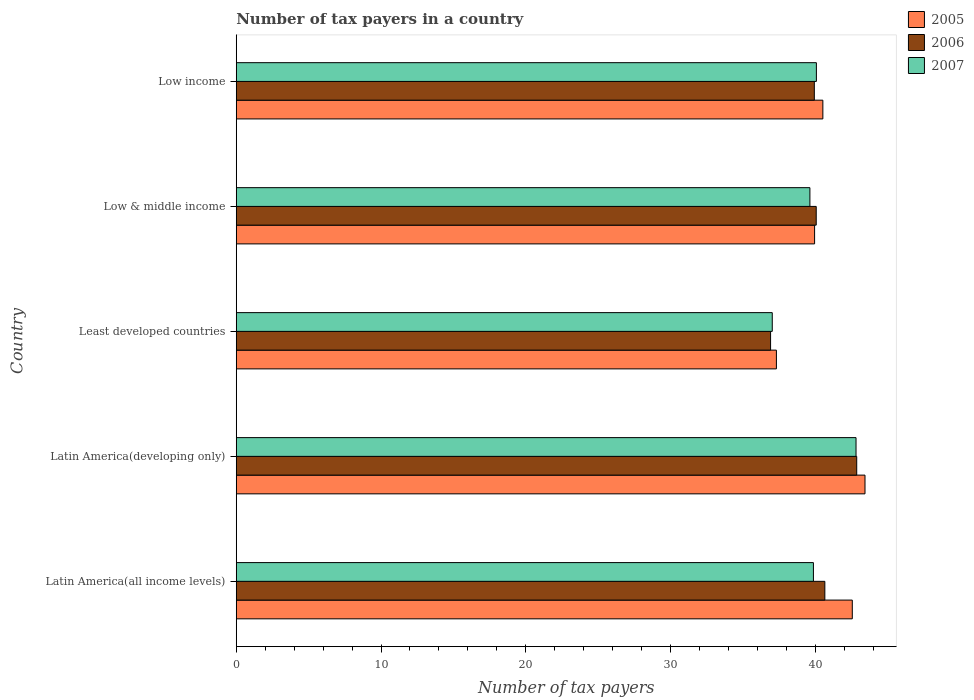How many groups of bars are there?
Offer a very short reply. 5. Are the number of bars per tick equal to the number of legend labels?
Keep it short and to the point. Yes. What is the label of the 4th group of bars from the top?
Your answer should be compact. Latin America(developing only). In how many cases, is the number of bars for a given country not equal to the number of legend labels?
Ensure brevity in your answer.  0. What is the number of tax payers in in 2005 in Latin America(all income levels)?
Make the answer very short. 42.55. Across all countries, what is the maximum number of tax payers in in 2005?
Offer a very short reply. 43.43. Across all countries, what is the minimum number of tax payers in in 2005?
Keep it short and to the point. 37.31. In which country was the number of tax payers in in 2007 maximum?
Offer a terse response. Latin America(developing only). In which country was the number of tax payers in in 2005 minimum?
Give a very brief answer. Least developed countries. What is the total number of tax payers in in 2005 in the graph?
Offer a terse response. 203.76. What is the difference between the number of tax payers in in 2007 in Latin America(all income levels) and that in Low & middle income?
Provide a short and direct response. 0.24. What is the difference between the number of tax payers in in 2006 in Low income and the number of tax payers in in 2005 in Least developed countries?
Your response must be concise. 2.62. What is the average number of tax payers in in 2005 per country?
Give a very brief answer. 40.75. What is the difference between the number of tax payers in in 2005 and number of tax payers in in 2007 in Latin America(developing only)?
Your response must be concise. 0.62. In how many countries, is the number of tax payers in in 2005 greater than 4 ?
Keep it short and to the point. 5. What is the ratio of the number of tax payers in in 2005 in Latin America(developing only) to that in Low & middle income?
Offer a terse response. 1.09. Is the number of tax payers in in 2005 in Least developed countries less than that in Low & middle income?
Provide a short and direct response. Yes. Is the difference between the number of tax payers in in 2005 in Least developed countries and Low & middle income greater than the difference between the number of tax payers in in 2007 in Least developed countries and Low & middle income?
Provide a succinct answer. No. What is the difference between the highest and the second highest number of tax payers in in 2005?
Your response must be concise. 0.88. What is the difference between the highest and the lowest number of tax payers in in 2005?
Give a very brief answer. 6.12. In how many countries, is the number of tax payers in in 2006 greater than the average number of tax payers in in 2006 taken over all countries?
Offer a terse response. 2. Is the sum of the number of tax payers in in 2005 in Latin America(developing only) and Low income greater than the maximum number of tax payers in in 2007 across all countries?
Keep it short and to the point. Yes. What does the 1st bar from the top in Low income represents?
Your response must be concise. 2007. How many bars are there?
Your answer should be compact. 15. Are all the bars in the graph horizontal?
Your answer should be compact. Yes. What is the difference between two consecutive major ticks on the X-axis?
Offer a very short reply. 10. Where does the legend appear in the graph?
Your answer should be very brief. Top right. How many legend labels are there?
Ensure brevity in your answer.  3. How are the legend labels stacked?
Make the answer very short. Vertical. What is the title of the graph?
Offer a very short reply. Number of tax payers in a country. Does "1989" appear as one of the legend labels in the graph?
Keep it short and to the point. No. What is the label or title of the X-axis?
Offer a very short reply. Number of tax payers. What is the label or title of the Y-axis?
Make the answer very short. Country. What is the Number of tax payers of 2005 in Latin America(all income levels)?
Provide a succinct answer. 42.55. What is the Number of tax payers in 2006 in Latin America(all income levels)?
Offer a very short reply. 40.66. What is the Number of tax payers of 2007 in Latin America(all income levels)?
Make the answer very short. 39.87. What is the Number of tax payers in 2005 in Latin America(developing only)?
Offer a terse response. 43.43. What is the Number of tax payers of 2006 in Latin America(developing only)?
Keep it short and to the point. 42.86. What is the Number of tax payers in 2007 in Latin America(developing only)?
Your response must be concise. 42.81. What is the Number of tax payers in 2005 in Least developed countries?
Provide a succinct answer. 37.31. What is the Number of tax payers of 2006 in Least developed countries?
Provide a succinct answer. 36.91. What is the Number of tax payers of 2007 in Least developed countries?
Your answer should be compact. 37.02. What is the Number of tax payers of 2005 in Low & middle income?
Offer a terse response. 39.95. What is the Number of tax payers in 2006 in Low & middle income?
Keep it short and to the point. 40.06. What is the Number of tax payers in 2007 in Low & middle income?
Provide a short and direct response. 39.62. What is the Number of tax payers of 2005 in Low income?
Offer a very short reply. 40.52. What is the Number of tax payers of 2006 in Low income?
Offer a very short reply. 39.93. What is the Number of tax payers in 2007 in Low income?
Make the answer very short. 40.07. Across all countries, what is the maximum Number of tax payers of 2005?
Your response must be concise. 43.43. Across all countries, what is the maximum Number of tax payers in 2006?
Give a very brief answer. 42.86. Across all countries, what is the maximum Number of tax payers of 2007?
Offer a terse response. 42.81. Across all countries, what is the minimum Number of tax payers in 2005?
Provide a succinct answer. 37.31. Across all countries, what is the minimum Number of tax payers of 2006?
Provide a succinct answer. 36.91. Across all countries, what is the minimum Number of tax payers in 2007?
Give a very brief answer. 37.02. What is the total Number of tax payers of 2005 in the graph?
Keep it short and to the point. 203.76. What is the total Number of tax payers in 2006 in the graph?
Your response must be concise. 200.41. What is the total Number of tax payers in 2007 in the graph?
Offer a terse response. 199.39. What is the difference between the Number of tax payers in 2005 in Latin America(all income levels) and that in Latin America(developing only)?
Keep it short and to the point. -0.88. What is the difference between the Number of tax payers in 2006 in Latin America(all income levels) and that in Latin America(developing only)?
Provide a short and direct response. -2.2. What is the difference between the Number of tax payers in 2007 in Latin America(all income levels) and that in Latin America(developing only)?
Your answer should be compact. -2.94. What is the difference between the Number of tax payers in 2005 in Latin America(all income levels) and that in Least developed countries?
Provide a short and direct response. 5.24. What is the difference between the Number of tax payers in 2006 in Latin America(all income levels) and that in Least developed countries?
Offer a terse response. 3.75. What is the difference between the Number of tax payers of 2007 in Latin America(all income levels) and that in Least developed countries?
Keep it short and to the point. 2.84. What is the difference between the Number of tax payers in 2005 in Latin America(all income levels) and that in Low & middle income?
Give a very brief answer. 2.6. What is the difference between the Number of tax payers of 2006 in Latin America(all income levels) and that in Low & middle income?
Give a very brief answer. 0.6. What is the difference between the Number of tax payers in 2007 in Latin America(all income levels) and that in Low & middle income?
Your answer should be very brief. 0.24. What is the difference between the Number of tax payers in 2005 in Latin America(all income levels) and that in Low income?
Give a very brief answer. 2.03. What is the difference between the Number of tax payers of 2006 in Latin America(all income levels) and that in Low income?
Your answer should be very brief. 0.73. What is the difference between the Number of tax payers in 2007 in Latin America(all income levels) and that in Low income?
Your answer should be very brief. -0.2. What is the difference between the Number of tax payers of 2005 in Latin America(developing only) and that in Least developed countries?
Keep it short and to the point. 6.12. What is the difference between the Number of tax payers of 2006 in Latin America(developing only) and that in Least developed countries?
Your answer should be very brief. 5.95. What is the difference between the Number of tax payers of 2007 in Latin America(developing only) and that in Least developed countries?
Your response must be concise. 5.79. What is the difference between the Number of tax payers of 2005 in Latin America(developing only) and that in Low & middle income?
Keep it short and to the point. 3.48. What is the difference between the Number of tax payers in 2006 in Latin America(developing only) and that in Low & middle income?
Ensure brevity in your answer.  2.8. What is the difference between the Number of tax payers of 2007 in Latin America(developing only) and that in Low & middle income?
Offer a very short reply. 3.19. What is the difference between the Number of tax payers in 2005 in Latin America(developing only) and that in Low income?
Your response must be concise. 2.91. What is the difference between the Number of tax payers of 2006 in Latin America(developing only) and that in Low income?
Your answer should be compact. 2.93. What is the difference between the Number of tax payers of 2007 in Latin America(developing only) and that in Low income?
Your response must be concise. 2.74. What is the difference between the Number of tax payers of 2005 in Least developed countries and that in Low & middle income?
Provide a succinct answer. -2.64. What is the difference between the Number of tax payers in 2006 in Least developed countries and that in Low & middle income?
Provide a short and direct response. -3.15. What is the difference between the Number of tax payers of 2007 in Least developed countries and that in Low & middle income?
Offer a very short reply. -2.6. What is the difference between the Number of tax payers in 2005 in Least developed countries and that in Low income?
Provide a short and direct response. -3.21. What is the difference between the Number of tax payers in 2006 in Least developed countries and that in Low income?
Ensure brevity in your answer.  -3.02. What is the difference between the Number of tax payers of 2007 in Least developed countries and that in Low income?
Provide a succinct answer. -3.05. What is the difference between the Number of tax payers in 2005 in Low & middle income and that in Low income?
Your answer should be compact. -0.57. What is the difference between the Number of tax payers in 2006 in Low & middle income and that in Low income?
Your answer should be compact. 0.13. What is the difference between the Number of tax payers of 2007 in Low & middle income and that in Low income?
Your answer should be compact. -0.45. What is the difference between the Number of tax payers of 2005 in Latin America(all income levels) and the Number of tax payers of 2006 in Latin America(developing only)?
Your answer should be compact. -0.31. What is the difference between the Number of tax payers of 2005 in Latin America(all income levels) and the Number of tax payers of 2007 in Latin America(developing only)?
Keep it short and to the point. -0.26. What is the difference between the Number of tax payers in 2006 in Latin America(all income levels) and the Number of tax payers in 2007 in Latin America(developing only)?
Make the answer very short. -2.15. What is the difference between the Number of tax payers in 2005 in Latin America(all income levels) and the Number of tax payers in 2006 in Least developed countries?
Ensure brevity in your answer.  5.64. What is the difference between the Number of tax payers in 2005 in Latin America(all income levels) and the Number of tax payers in 2007 in Least developed countries?
Provide a short and direct response. 5.53. What is the difference between the Number of tax payers of 2006 in Latin America(all income levels) and the Number of tax payers of 2007 in Least developed countries?
Make the answer very short. 3.63. What is the difference between the Number of tax payers of 2005 in Latin America(all income levels) and the Number of tax payers of 2006 in Low & middle income?
Offer a very short reply. 2.49. What is the difference between the Number of tax payers in 2005 in Latin America(all income levels) and the Number of tax payers in 2007 in Low & middle income?
Make the answer very short. 2.93. What is the difference between the Number of tax payers in 2006 in Latin America(all income levels) and the Number of tax payers in 2007 in Low & middle income?
Keep it short and to the point. 1.03. What is the difference between the Number of tax payers of 2005 in Latin America(all income levels) and the Number of tax payers of 2006 in Low income?
Keep it short and to the point. 2.62. What is the difference between the Number of tax payers in 2005 in Latin America(all income levels) and the Number of tax payers in 2007 in Low income?
Your answer should be very brief. 2.48. What is the difference between the Number of tax payers in 2006 in Latin America(all income levels) and the Number of tax payers in 2007 in Low income?
Your answer should be compact. 0.58. What is the difference between the Number of tax payers in 2005 in Latin America(developing only) and the Number of tax payers in 2006 in Least developed countries?
Your answer should be compact. 6.52. What is the difference between the Number of tax payers of 2005 in Latin America(developing only) and the Number of tax payers of 2007 in Least developed countries?
Keep it short and to the point. 6.41. What is the difference between the Number of tax payers in 2006 in Latin America(developing only) and the Number of tax payers in 2007 in Least developed countries?
Ensure brevity in your answer.  5.83. What is the difference between the Number of tax payers in 2005 in Latin America(developing only) and the Number of tax payers in 2006 in Low & middle income?
Offer a terse response. 3.37. What is the difference between the Number of tax payers of 2005 in Latin America(developing only) and the Number of tax payers of 2007 in Low & middle income?
Ensure brevity in your answer.  3.8. What is the difference between the Number of tax payers of 2006 in Latin America(developing only) and the Number of tax payers of 2007 in Low & middle income?
Your response must be concise. 3.23. What is the difference between the Number of tax payers of 2005 in Latin America(developing only) and the Number of tax payers of 2007 in Low income?
Offer a terse response. 3.36. What is the difference between the Number of tax payers in 2006 in Latin America(developing only) and the Number of tax payers in 2007 in Low income?
Your answer should be compact. 2.79. What is the difference between the Number of tax payers in 2005 in Least developed countries and the Number of tax payers in 2006 in Low & middle income?
Your answer should be very brief. -2.75. What is the difference between the Number of tax payers in 2005 in Least developed countries and the Number of tax payers in 2007 in Low & middle income?
Make the answer very short. -2.31. What is the difference between the Number of tax payers in 2006 in Least developed countries and the Number of tax payers in 2007 in Low & middle income?
Give a very brief answer. -2.72. What is the difference between the Number of tax payers in 2005 in Least developed countries and the Number of tax payers in 2006 in Low income?
Offer a very short reply. -2.62. What is the difference between the Number of tax payers in 2005 in Least developed countries and the Number of tax payers in 2007 in Low income?
Give a very brief answer. -2.76. What is the difference between the Number of tax payers of 2006 in Least developed countries and the Number of tax payers of 2007 in Low income?
Your response must be concise. -3.16. What is the difference between the Number of tax payers in 2005 in Low & middle income and the Number of tax payers in 2006 in Low income?
Provide a short and direct response. 0.02. What is the difference between the Number of tax payers of 2005 in Low & middle income and the Number of tax payers of 2007 in Low income?
Offer a terse response. -0.12. What is the difference between the Number of tax payers of 2006 in Low & middle income and the Number of tax payers of 2007 in Low income?
Your response must be concise. -0.01. What is the average Number of tax payers in 2005 per country?
Make the answer very short. 40.75. What is the average Number of tax payers of 2006 per country?
Provide a succinct answer. 40.08. What is the average Number of tax payers of 2007 per country?
Make the answer very short. 39.88. What is the difference between the Number of tax payers in 2005 and Number of tax payers in 2006 in Latin America(all income levels)?
Your response must be concise. 1.9. What is the difference between the Number of tax payers in 2005 and Number of tax payers in 2007 in Latin America(all income levels)?
Ensure brevity in your answer.  2.69. What is the difference between the Number of tax payers in 2006 and Number of tax payers in 2007 in Latin America(all income levels)?
Your response must be concise. 0.79. What is the difference between the Number of tax payers in 2005 and Number of tax payers in 2007 in Latin America(developing only)?
Your answer should be compact. 0.62. What is the difference between the Number of tax payers in 2006 and Number of tax payers in 2007 in Latin America(developing only)?
Your answer should be compact. 0.05. What is the difference between the Number of tax payers of 2005 and Number of tax payers of 2006 in Least developed countries?
Your answer should be very brief. 0.4. What is the difference between the Number of tax payers in 2005 and Number of tax payers in 2007 in Least developed countries?
Offer a terse response. 0.29. What is the difference between the Number of tax payers of 2006 and Number of tax payers of 2007 in Least developed countries?
Offer a very short reply. -0.12. What is the difference between the Number of tax payers of 2005 and Number of tax payers of 2006 in Low & middle income?
Your response must be concise. -0.11. What is the difference between the Number of tax payers of 2005 and Number of tax payers of 2007 in Low & middle income?
Provide a succinct answer. 0.32. What is the difference between the Number of tax payers in 2006 and Number of tax payers in 2007 in Low & middle income?
Your answer should be very brief. 0.44. What is the difference between the Number of tax payers in 2005 and Number of tax payers in 2006 in Low income?
Provide a succinct answer. 0.59. What is the difference between the Number of tax payers of 2005 and Number of tax payers of 2007 in Low income?
Your response must be concise. 0.45. What is the difference between the Number of tax payers of 2006 and Number of tax payers of 2007 in Low income?
Provide a short and direct response. -0.14. What is the ratio of the Number of tax payers in 2005 in Latin America(all income levels) to that in Latin America(developing only)?
Give a very brief answer. 0.98. What is the ratio of the Number of tax payers of 2006 in Latin America(all income levels) to that in Latin America(developing only)?
Offer a very short reply. 0.95. What is the ratio of the Number of tax payers in 2007 in Latin America(all income levels) to that in Latin America(developing only)?
Provide a succinct answer. 0.93. What is the ratio of the Number of tax payers in 2005 in Latin America(all income levels) to that in Least developed countries?
Your response must be concise. 1.14. What is the ratio of the Number of tax payers of 2006 in Latin America(all income levels) to that in Least developed countries?
Offer a terse response. 1.1. What is the ratio of the Number of tax payers in 2007 in Latin America(all income levels) to that in Least developed countries?
Your answer should be compact. 1.08. What is the ratio of the Number of tax payers of 2005 in Latin America(all income levels) to that in Low & middle income?
Give a very brief answer. 1.07. What is the ratio of the Number of tax payers of 2006 in Latin America(all income levels) to that in Low & middle income?
Offer a terse response. 1.01. What is the ratio of the Number of tax payers in 2005 in Latin America(all income levels) to that in Low income?
Your answer should be very brief. 1.05. What is the ratio of the Number of tax payers of 2006 in Latin America(all income levels) to that in Low income?
Give a very brief answer. 1.02. What is the ratio of the Number of tax payers in 2005 in Latin America(developing only) to that in Least developed countries?
Keep it short and to the point. 1.16. What is the ratio of the Number of tax payers of 2006 in Latin America(developing only) to that in Least developed countries?
Provide a succinct answer. 1.16. What is the ratio of the Number of tax payers of 2007 in Latin America(developing only) to that in Least developed countries?
Offer a terse response. 1.16. What is the ratio of the Number of tax payers in 2005 in Latin America(developing only) to that in Low & middle income?
Ensure brevity in your answer.  1.09. What is the ratio of the Number of tax payers in 2006 in Latin America(developing only) to that in Low & middle income?
Your response must be concise. 1.07. What is the ratio of the Number of tax payers of 2007 in Latin America(developing only) to that in Low & middle income?
Your answer should be compact. 1.08. What is the ratio of the Number of tax payers of 2005 in Latin America(developing only) to that in Low income?
Your answer should be compact. 1.07. What is the ratio of the Number of tax payers of 2006 in Latin America(developing only) to that in Low income?
Make the answer very short. 1.07. What is the ratio of the Number of tax payers in 2007 in Latin America(developing only) to that in Low income?
Provide a short and direct response. 1.07. What is the ratio of the Number of tax payers of 2005 in Least developed countries to that in Low & middle income?
Provide a short and direct response. 0.93. What is the ratio of the Number of tax payers in 2006 in Least developed countries to that in Low & middle income?
Provide a succinct answer. 0.92. What is the ratio of the Number of tax payers in 2007 in Least developed countries to that in Low & middle income?
Your response must be concise. 0.93. What is the ratio of the Number of tax payers of 2005 in Least developed countries to that in Low income?
Make the answer very short. 0.92. What is the ratio of the Number of tax payers of 2006 in Least developed countries to that in Low income?
Provide a short and direct response. 0.92. What is the ratio of the Number of tax payers of 2007 in Least developed countries to that in Low income?
Provide a succinct answer. 0.92. What is the ratio of the Number of tax payers in 2005 in Low & middle income to that in Low income?
Offer a terse response. 0.99. What is the ratio of the Number of tax payers of 2006 in Low & middle income to that in Low income?
Give a very brief answer. 1. What is the difference between the highest and the second highest Number of tax payers in 2005?
Give a very brief answer. 0.88. What is the difference between the highest and the second highest Number of tax payers of 2006?
Give a very brief answer. 2.2. What is the difference between the highest and the second highest Number of tax payers of 2007?
Ensure brevity in your answer.  2.74. What is the difference between the highest and the lowest Number of tax payers of 2005?
Your response must be concise. 6.12. What is the difference between the highest and the lowest Number of tax payers of 2006?
Ensure brevity in your answer.  5.95. What is the difference between the highest and the lowest Number of tax payers of 2007?
Your answer should be compact. 5.79. 